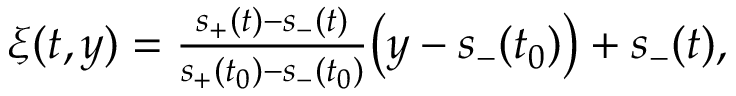<formula> <loc_0><loc_0><loc_500><loc_500>\begin{array} { r } { \xi ( t , y ) = \frac { s _ { + } ( t ) - s _ { - } ( t ) } { s _ { + } ( t _ { 0 } ) - s _ { - } ( t _ { 0 } ) } \left ( y - s _ { - } ( t _ { 0 } ) \right ) + s _ { - } ( t ) , } \end{array}</formula> 